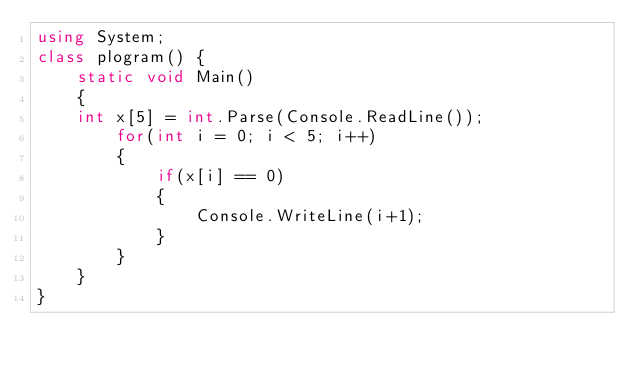<code> <loc_0><loc_0><loc_500><loc_500><_C#_>using System;
class plogram() {
    static void Main()
    {
    int x[5] = int.Parse(Console.ReadLine());
        for(int i = 0; i < 5; i++) 
        {
            if(x[i] == 0) 
            {
                Console.WriteLine(i+1);
            }
        }
    }
}</code> 